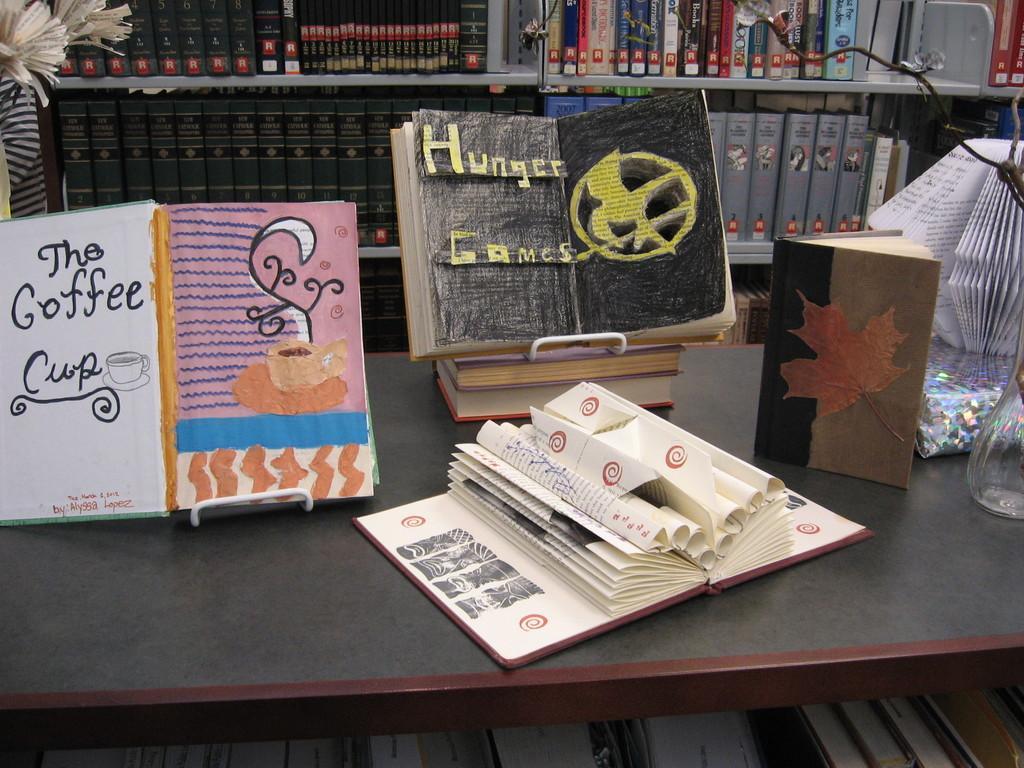Describe this image in one or two sentences. In there are some books on table, there is a flower vase on right side corner and on the background there are racks with full of books. 